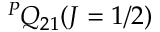Convert formula to latex. <formula><loc_0><loc_0><loc_500><loc_500>^ { P } Q _ { 2 1 } ( J = 1 / 2 )</formula> 